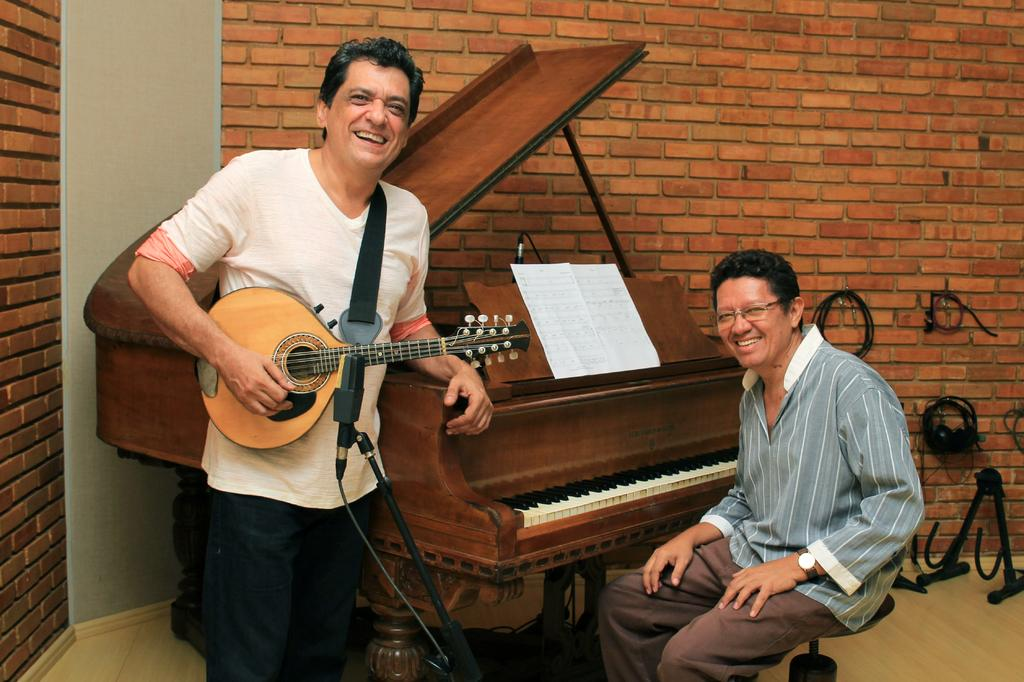How many people are in the image? There are two persons in the image. What are the two persons doing in the image? One person is sitting in front of a piano, and the other person is standing and holding a guitar. What can be seen in the background of the image? There is a wall visible in the background of the image. What type of cloth is draped over the piano in the image? There is no cloth draped over the piano in the image. Can you see any flowers in the image? There are no flowers visible in the image. 